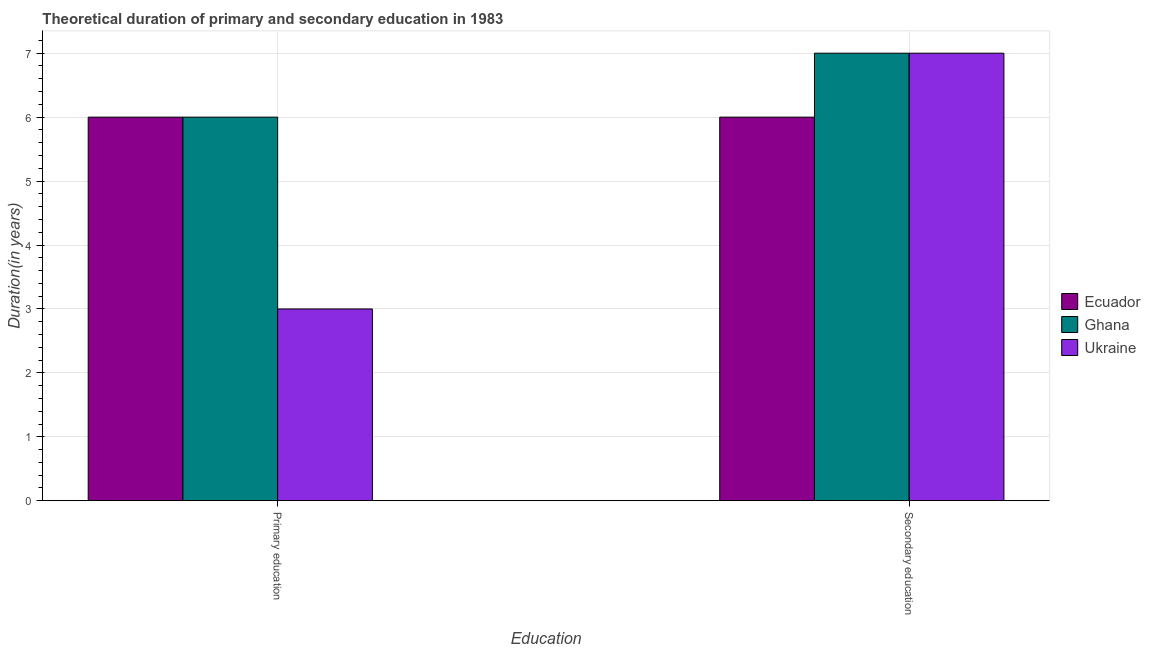Are the number of bars per tick equal to the number of legend labels?
Offer a terse response. Yes. Are the number of bars on each tick of the X-axis equal?
Give a very brief answer. Yes. How many bars are there on the 2nd tick from the left?
Make the answer very short. 3. How many bars are there on the 2nd tick from the right?
Your answer should be very brief. 3. What is the duration of secondary education in Ukraine?
Give a very brief answer. 7. Across all countries, what is the maximum duration of secondary education?
Keep it short and to the point. 7. Across all countries, what is the minimum duration of secondary education?
Make the answer very short. 6. In which country was the duration of primary education maximum?
Provide a succinct answer. Ecuador. In which country was the duration of secondary education minimum?
Offer a very short reply. Ecuador. What is the total duration of secondary education in the graph?
Give a very brief answer. 20. What is the difference between the duration of secondary education in Ukraine and that in Ecuador?
Provide a succinct answer. 1. What is the difference between the duration of secondary education in Ecuador and the duration of primary education in Ghana?
Offer a terse response. 0. What is the average duration of secondary education per country?
Provide a short and direct response. 6.67. What is the difference between the duration of primary education and duration of secondary education in Ghana?
Your answer should be very brief. -1. In how many countries, is the duration of primary education greater than 6.2 years?
Provide a short and direct response. 0. What is the ratio of the duration of primary education in Ecuador to that in Ghana?
Provide a short and direct response. 1. What does the 3rd bar from the right in Primary education represents?
Provide a short and direct response. Ecuador. How many bars are there?
Offer a very short reply. 6. Are all the bars in the graph horizontal?
Keep it short and to the point. No. How many countries are there in the graph?
Your answer should be very brief. 3. What is the difference between two consecutive major ticks on the Y-axis?
Offer a terse response. 1. Are the values on the major ticks of Y-axis written in scientific E-notation?
Provide a succinct answer. No. How many legend labels are there?
Your response must be concise. 3. How are the legend labels stacked?
Your answer should be compact. Vertical. What is the title of the graph?
Your answer should be compact. Theoretical duration of primary and secondary education in 1983. What is the label or title of the X-axis?
Make the answer very short. Education. What is the label or title of the Y-axis?
Keep it short and to the point. Duration(in years). What is the Duration(in years) of Ecuador in Primary education?
Ensure brevity in your answer.  6. What is the Duration(in years) of Ecuador in Secondary education?
Make the answer very short. 6. Across all Education, what is the minimum Duration(in years) in Ukraine?
Your response must be concise. 3. What is the total Duration(in years) of Ghana in the graph?
Your answer should be very brief. 13. What is the difference between the Duration(in years) of Ecuador in Primary education and that in Secondary education?
Provide a short and direct response. 0. What is the difference between the Duration(in years) in Ghana in Primary education and that in Secondary education?
Offer a terse response. -1. What is the difference between the Duration(in years) in Ecuador in Primary education and the Duration(in years) in Ukraine in Secondary education?
Offer a terse response. -1. What is the difference between the Duration(in years) of Ghana in Primary education and the Duration(in years) of Ukraine in Secondary education?
Your response must be concise. -1. What is the average Duration(in years) in Ecuador per Education?
Offer a very short reply. 6. What is the average Duration(in years) in Ukraine per Education?
Offer a very short reply. 5. What is the difference between the Duration(in years) in Ecuador and Duration(in years) in Ghana in Primary education?
Ensure brevity in your answer.  0. What is the difference between the Duration(in years) of Ecuador and Duration(in years) of Ukraine in Primary education?
Your answer should be compact. 3. What is the difference between the Duration(in years) in Ecuador and Duration(in years) in Ghana in Secondary education?
Your response must be concise. -1. What is the difference between the Duration(in years) of Ghana and Duration(in years) of Ukraine in Secondary education?
Offer a terse response. 0. What is the ratio of the Duration(in years) of Ecuador in Primary education to that in Secondary education?
Your answer should be compact. 1. What is the ratio of the Duration(in years) of Ghana in Primary education to that in Secondary education?
Keep it short and to the point. 0.86. What is the ratio of the Duration(in years) of Ukraine in Primary education to that in Secondary education?
Keep it short and to the point. 0.43. What is the difference between the highest and the second highest Duration(in years) of Ecuador?
Give a very brief answer. 0. What is the difference between the highest and the second highest Duration(in years) in Ghana?
Your response must be concise. 1. What is the difference between the highest and the lowest Duration(in years) in Ecuador?
Offer a terse response. 0. What is the difference between the highest and the lowest Duration(in years) of Ukraine?
Ensure brevity in your answer.  4. 